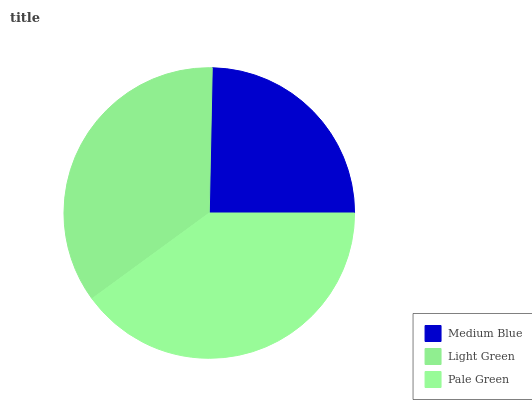Is Medium Blue the minimum?
Answer yes or no. Yes. Is Pale Green the maximum?
Answer yes or no. Yes. Is Light Green the minimum?
Answer yes or no. No. Is Light Green the maximum?
Answer yes or no. No. Is Light Green greater than Medium Blue?
Answer yes or no. Yes. Is Medium Blue less than Light Green?
Answer yes or no. Yes. Is Medium Blue greater than Light Green?
Answer yes or no. No. Is Light Green less than Medium Blue?
Answer yes or no. No. Is Light Green the high median?
Answer yes or no. Yes. Is Light Green the low median?
Answer yes or no. Yes. Is Pale Green the high median?
Answer yes or no. No. Is Medium Blue the low median?
Answer yes or no. No. 